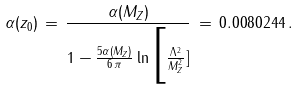Convert formula to latex. <formula><loc_0><loc_0><loc_500><loc_500>\alpha ( z _ { 0 } ) \, = \, \frac { \alpha ( M _ { Z } ) } { 1 - \frac { 5 \alpha ( M _ { Z } ) } { 6 \, \pi } \ln \Big [ \frac { \Lambda ^ { 2 } } { M _ { Z } ^ { 2 } } ] } \, = \, 0 . 0 0 8 0 2 4 4 \, .</formula> 